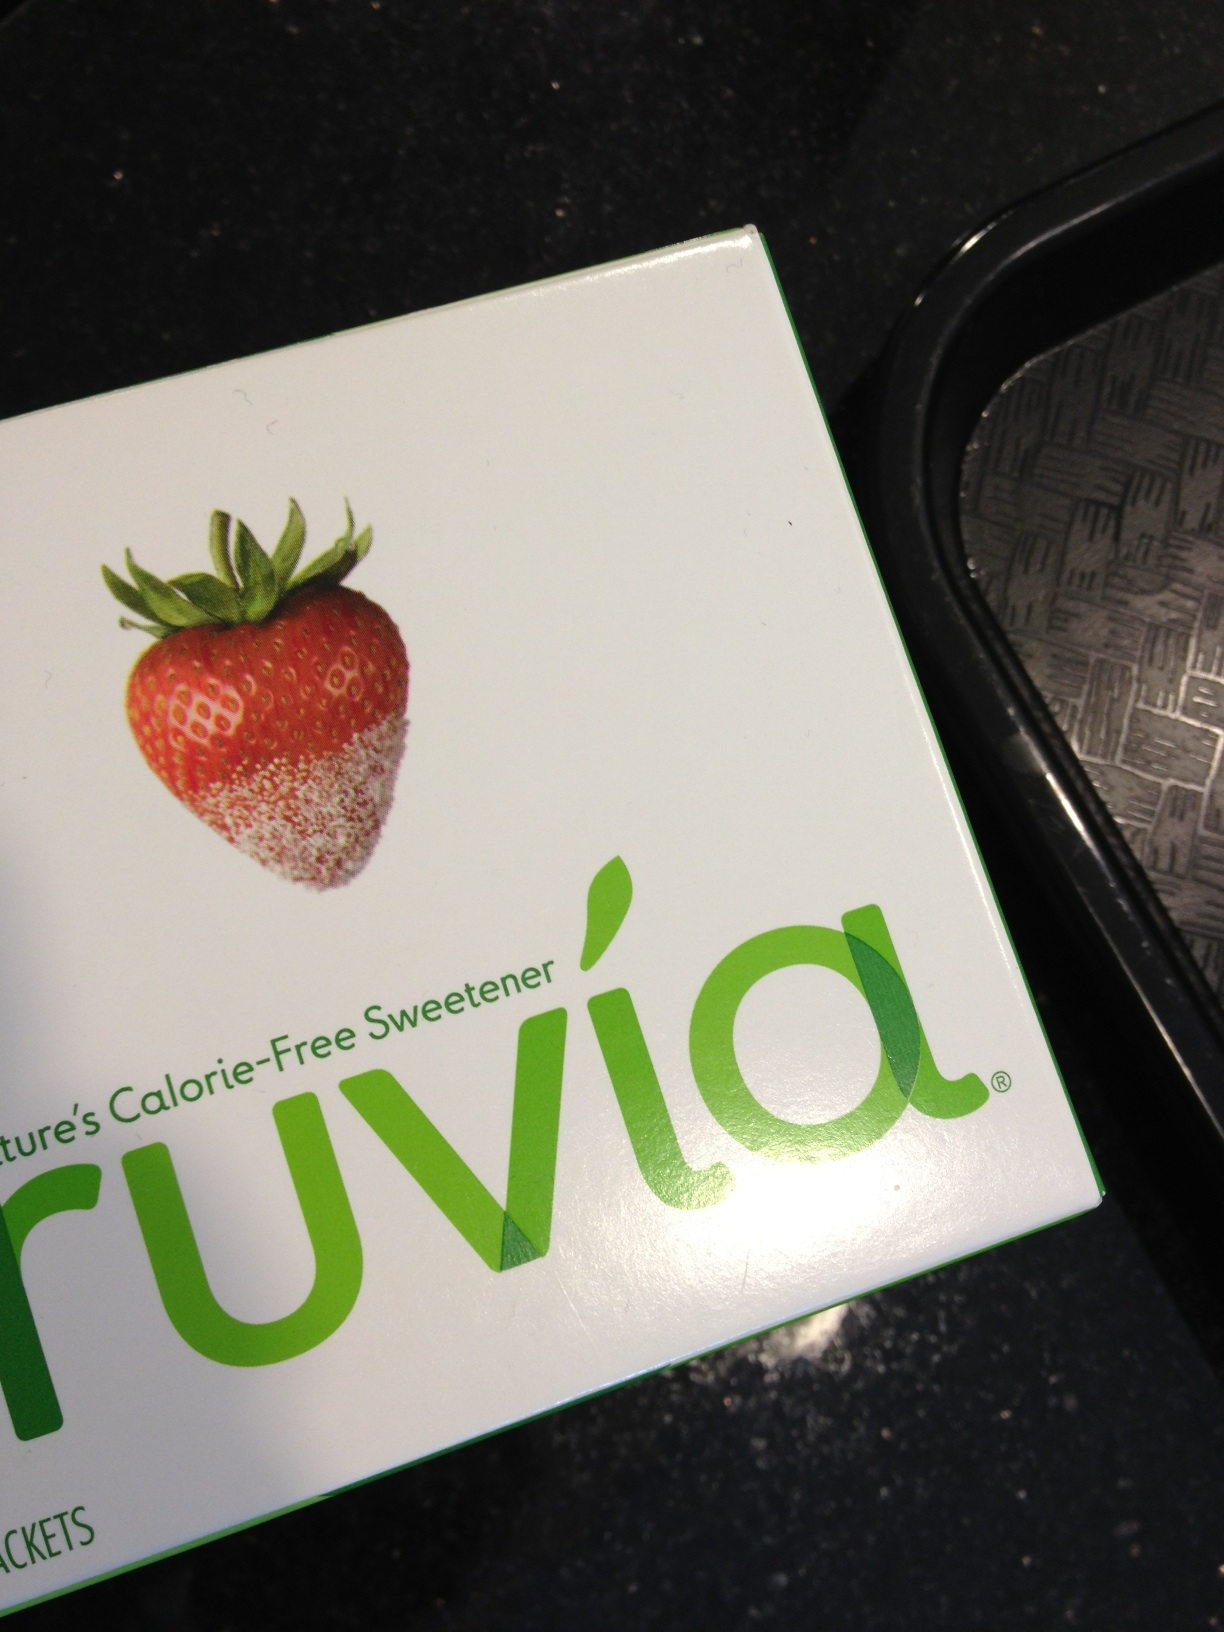What are some common uses of Truvia? Truvia is commonly used as a sugar substitute in beverages like coffee and tea, and in various food items such as cereals, baked goods, and desserts. It provides a sweet taste without the calories, making it a popular choice among those managing calorie intake or with dietary restrictions. 